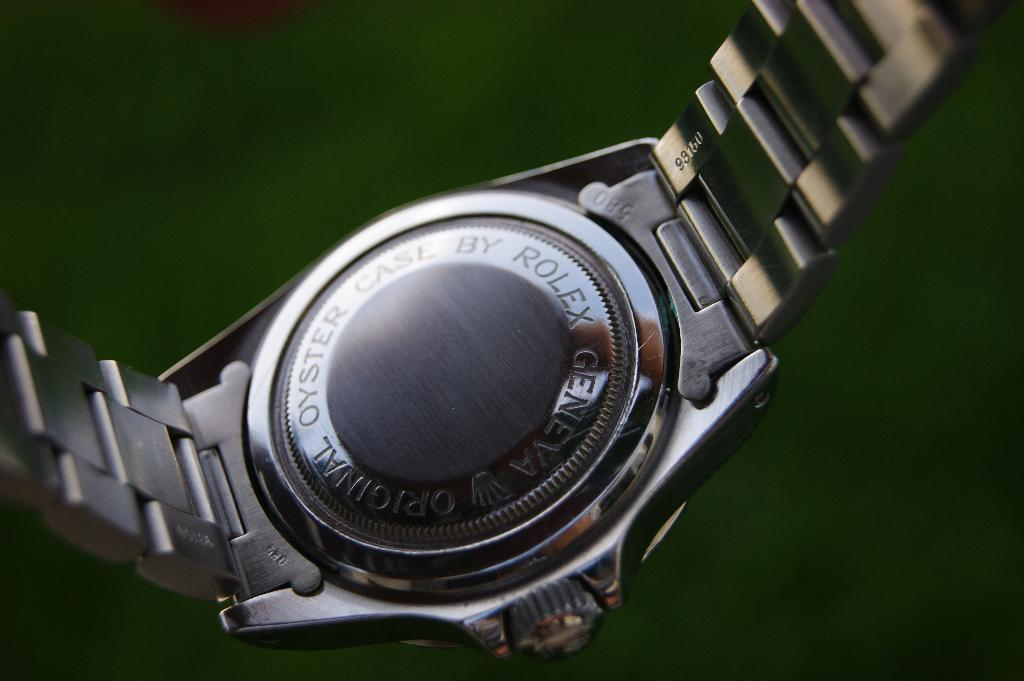What object is the main focus of the image? There is a watch in the image. What can be observed in the background of the image? The background of the image is green in color. What time is the manager discussing during the meeting in the image? There is no manager, meeting, or discussion present in the image; it only features a watch and a green background. 